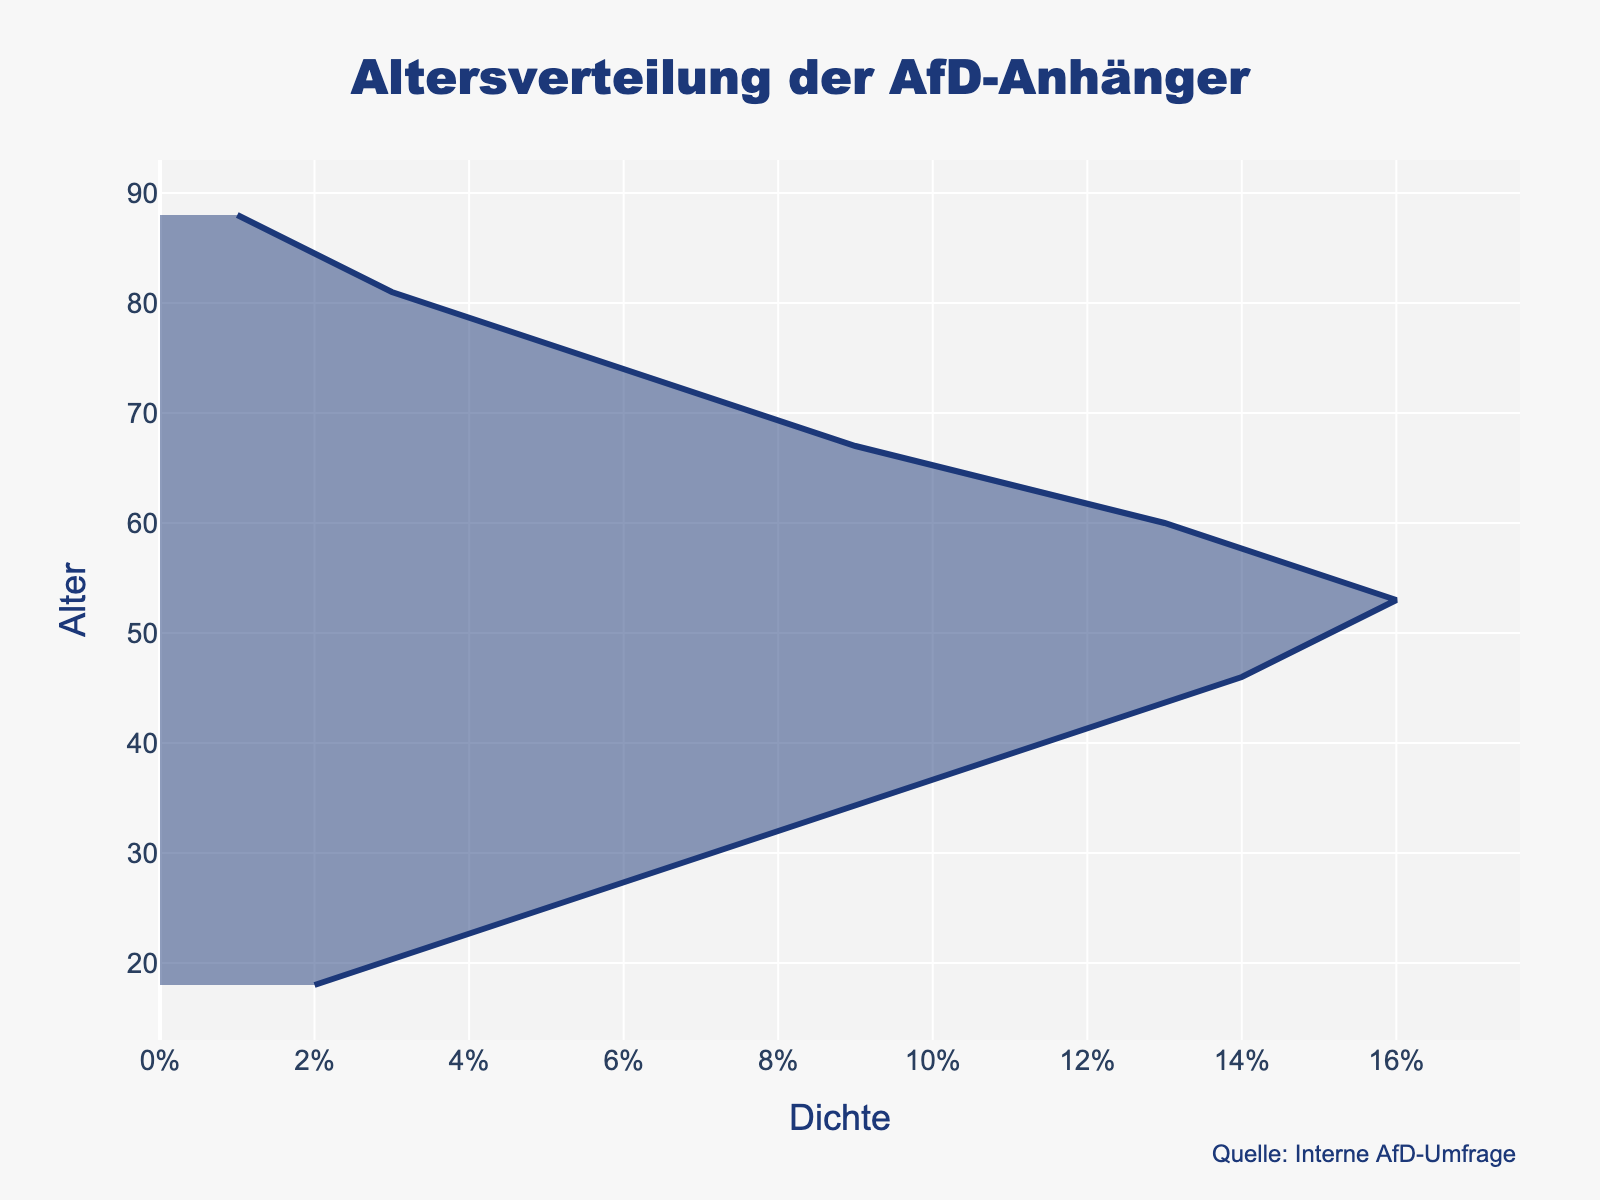what is the title of the plot? The title is displayed prominently at the top of the plot. It helps in identifying what the plot is about.
Answer: "Altersverteilung der AfD-Anhänger" What is the most common age range among AfD supporters? Identify the age range where the density is the highest, which indicates the most common age group. The highest density value is 0.16, corresponding to the age of 53.
Answer: 53 Which age group has the lowest density of AfD supporters? Check for the ages corresponding to the lowest density values. Here, the density value is 0.01, corresponding to the age of 88.
Answer: 88 How does the density of supporters change from age 18 to 53? Observe how the density values increase from 0.02 at age 18 to the peak value of 0.16 at age 53. It suggests a steady increase.
Answer: It increases What is the density for AfD supporters at the age of 60? Look at the plot and find the corresponding density value for the age of 60. The plot shows that the density at age 60 is 0.13.
Answer: 0.13 Compare the densities of AfD supporters at ages 25 and 74. Which one is higher? Refer to the densities at ages 25 and 74. The density at age 25 is 0.05 and at age 74 is 0.06. The density at age 74 is higher.
Answer: 74 What is the average density of AfD supporters between ages 32 to 74? Add the density values and divide by the number of values. (0.08 + 0.11 + 0.14 + 0.16 + 0.13 + 0.09 + 0.06) = 0.77 / 7 = 0.11
Answer: 0.11 Which age group shows a sharp decline in density after the peak? After the peak at age 53 with a density of 0.16, there is a sharp decline to age 60 with a density of 0.13.
Answer: 53 to 60 How is the visual layout of the plot customized to highlight the AfD supporters' age distribution? The plot uses a title, axes labels, specific line and fill colors, and annotations specifying the source to make the data clear and visually appealing.
Answer: Specific title, axes labels, colors, and annotations Between which ages does the density of AfD supporters remain relatively stable? Identify the range where changes in density are minimal. Densities between ages 25 (0.05) to 32 (0.08) and 67 (0.09) to 74 (0.06) show relatively less fluctuation compared to others.
Answer: 25 to 32 and 67 to 74 